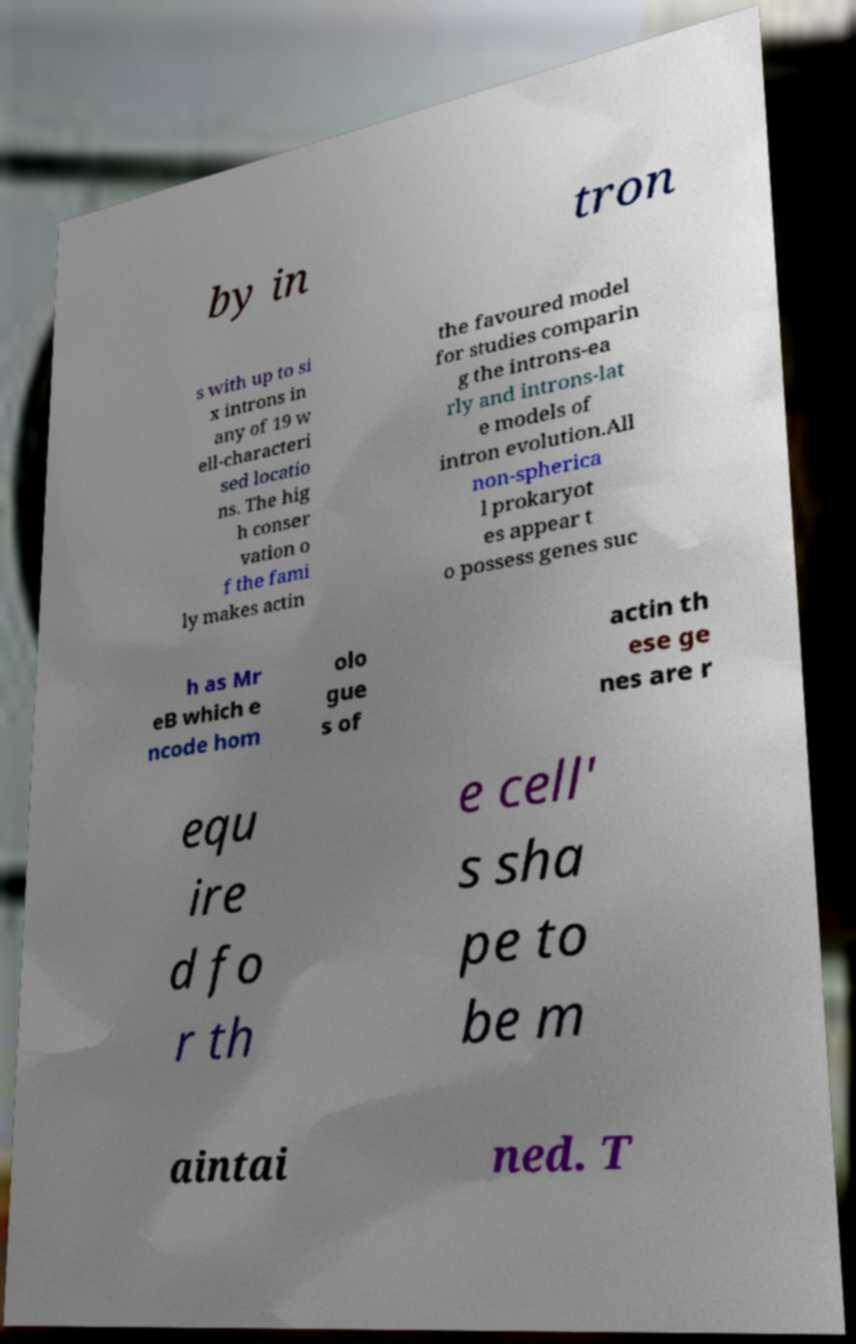Could you assist in decoding the text presented in this image and type it out clearly? by in tron s with up to si x introns in any of 19 w ell-characteri sed locatio ns. The hig h conser vation o f the fami ly makes actin the favoured model for studies comparin g the introns-ea rly and introns-lat e models of intron evolution.All non-spherica l prokaryot es appear t o possess genes suc h as Mr eB which e ncode hom olo gue s of actin th ese ge nes are r equ ire d fo r th e cell' s sha pe to be m aintai ned. T 